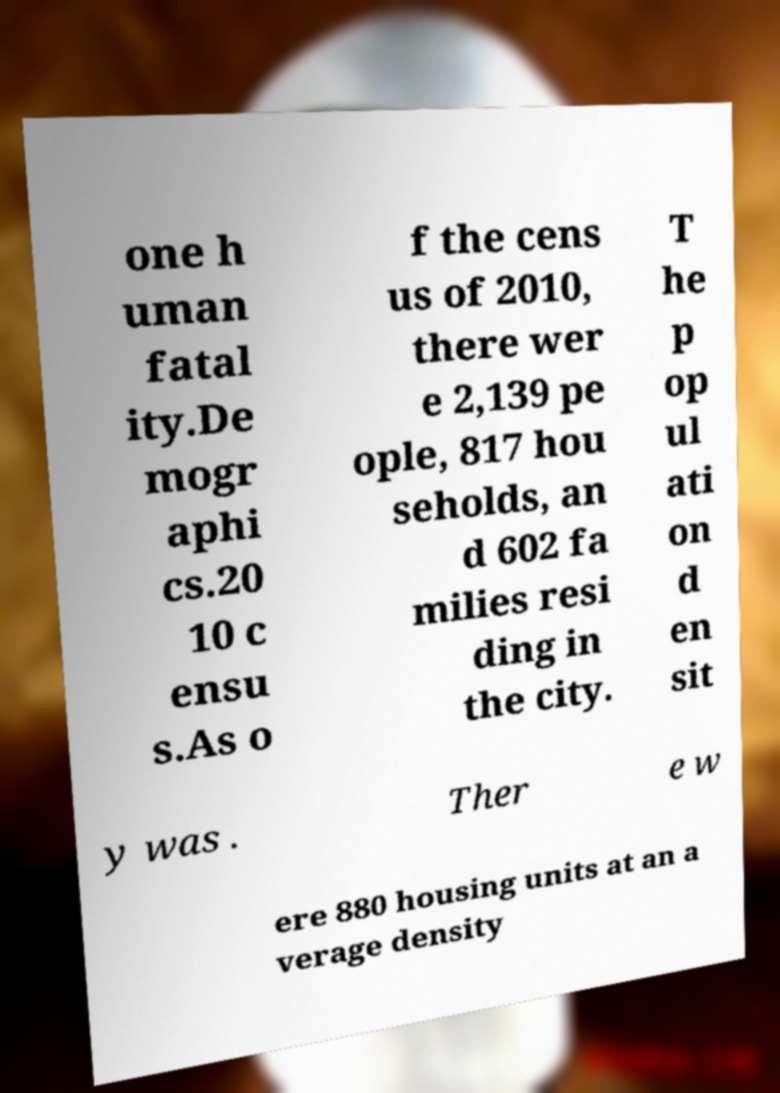For documentation purposes, I need the text within this image transcribed. Could you provide that? one h uman fatal ity.De mogr aphi cs.20 10 c ensu s.As o f the cens us of 2010, there wer e 2,139 pe ople, 817 hou seholds, an d 602 fa milies resi ding in the city. T he p op ul ati on d en sit y was . Ther e w ere 880 housing units at an a verage density 